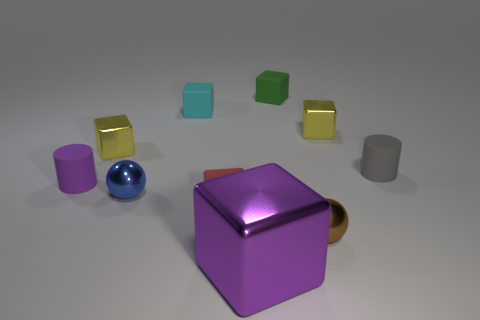Is there any other thing that has the same size as the purple shiny object?
Offer a terse response. No. There is a rubber cylinder that is to the left of the yellow object that is on the left side of the tiny cyan block; what size is it?
Provide a succinct answer. Small. There is another small cylinder that is the same material as the tiny gray cylinder; what is its color?
Ensure brevity in your answer.  Purple. There is a rubber cylinder that is on the right side of the tiny purple matte thing; what is its color?
Keep it short and to the point. Gray. What number of metallic spheres have the same color as the big cube?
Offer a very short reply. 0. Is the number of tiny green blocks in front of the big metallic thing less than the number of cyan things that are behind the tiny purple rubber object?
Give a very brief answer. Yes. What number of tiny yellow shiny cubes are right of the cyan rubber thing?
Provide a succinct answer. 1. Is there a brown object that has the same material as the small blue object?
Give a very brief answer. Yes. Are there more yellow blocks that are to the left of the brown shiny object than blue spheres that are in front of the big metal object?
Give a very brief answer. Yes. The purple metal thing is what size?
Offer a terse response. Large. 